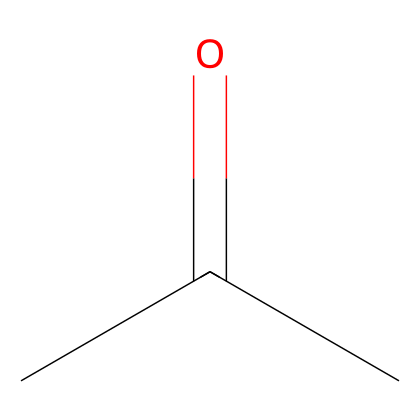What is the molecular formula of this compound? The SMILES representation CC(=O)C indicates that there are 3 carbon atoms (C), 6 hydrogen atoms (H), and 1 oxygen atom (O), which collectively represent the molecular formula C3H6O.
Answer: C3H6O How many hydrogen atoms does acetone contain? From the molecular formula C3H6O, it's evident that there are 6 hydrogen atoms present in acetone.
Answer: 6 What type of functional group is present in acetone? The presence of the carbonyl group (C=O), represented by the "C(=O)" in the SMILES notation, indicates that acetone has a ketone functional group.
Answer: ketone What is the total number of bonds in acetone? In the structure of acetone, there are a total of 9 bonds: 3 C-C bonds and 6 C-H bonds (involving 6 hydrogen atoms), plus 1 C=O double bond. Adding them gives a total of 9.
Answer: 9 How does the structure of acetone influence its solvent capabilities? The presence of a carbonyl group allows acetone to interact with other polar molecules through dipole-dipole interactions, enhancing its capability as a polar solvent.
Answer: enhances solvent capabilities What is the reason acetone evaporates quickly? Acetone has low molecular weight and relatively weak intermolecular forces (due to the polar functional group), which allows for rapid evaporation at room temperature.
Answer: low molecular weight Why is acetone considered a good solvent in cleaning products? Acetone is effective at dissolving oils and organic compounds due to its polar nature and ability to interact with various chemical types, making it a versatile solvent in cleaning solutions.
Answer: versatile solvent 